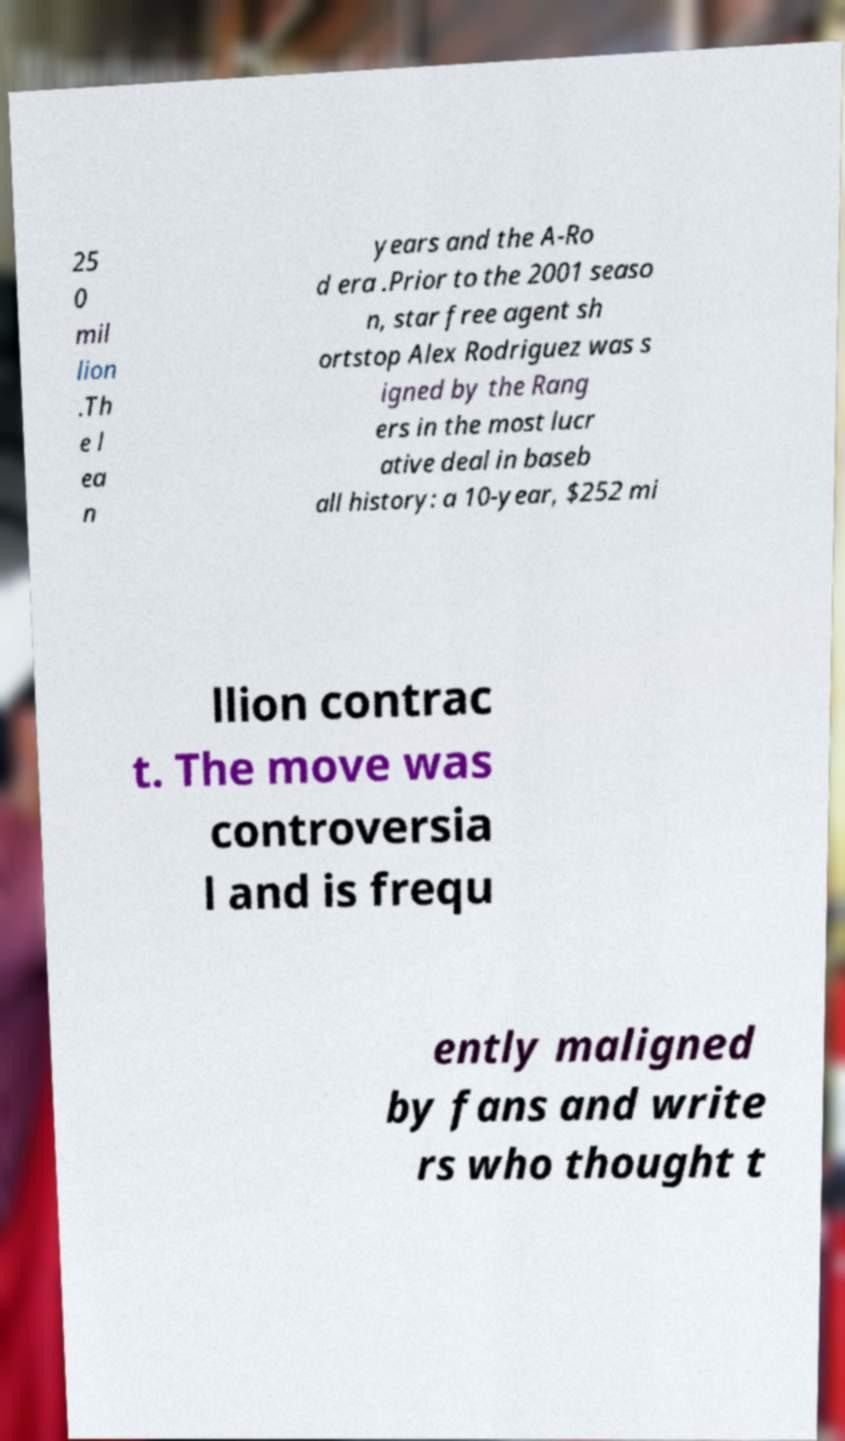Please read and relay the text visible in this image. What does it say? 25 0 mil lion .Th e l ea n years and the A-Ro d era .Prior to the 2001 seaso n, star free agent sh ortstop Alex Rodriguez was s igned by the Rang ers in the most lucr ative deal in baseb all history: a 10-year, $252 mi llion contrac t. The move was controversia l and is frequ ently maligned by fans and write rs who thought t 